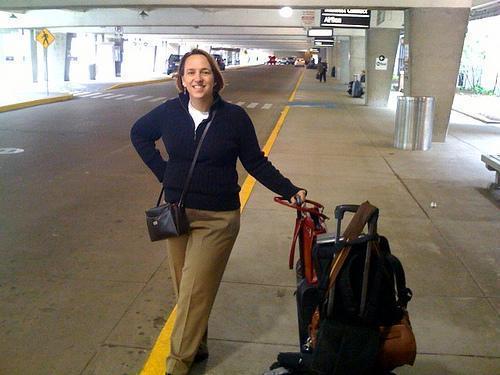What is she doing?
Answer the question by selecting the correct answer among the 4 following choices.
Options: Stealing luggage, returning luggage, posing, exercising. Posing. 